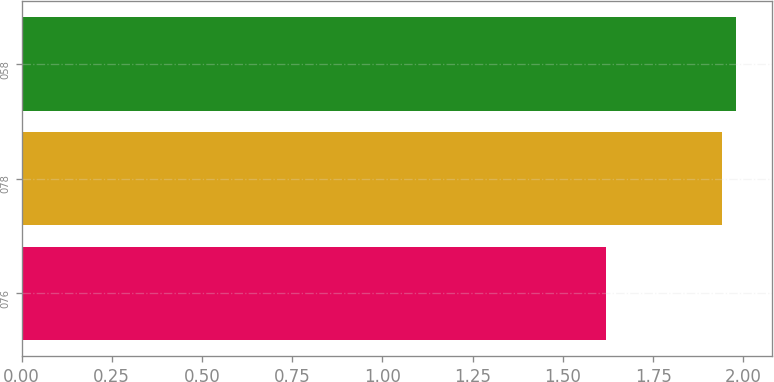<chart> <loc_0><loc_0><loc_500><loc_500><bar_chart><fcel>076<fcel>078<fcel>058<nl><fcel>1.62<fcel>1.94<fcel>1.98<nl></chart> 